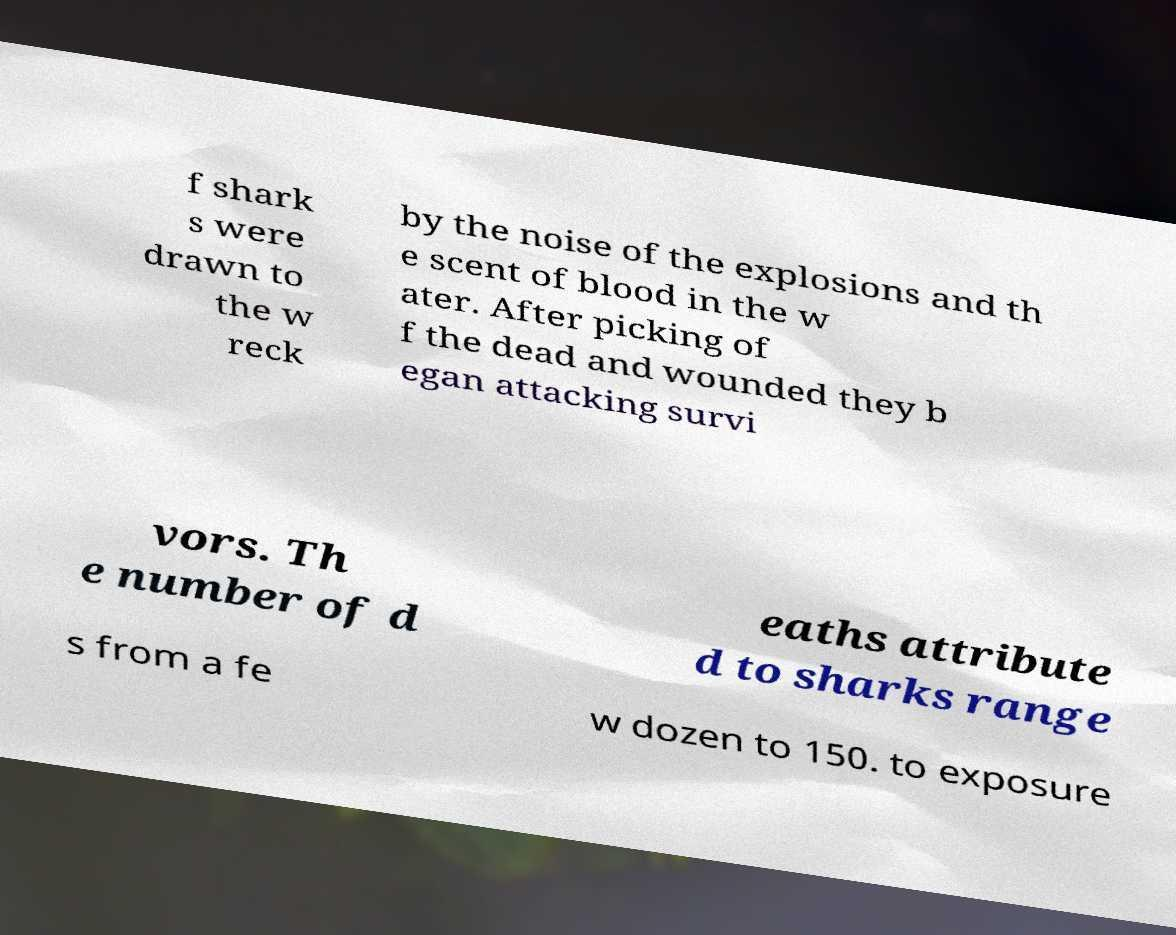There's text embedded in this image that I need extracted. Can you transcribe it verbatim? f shark s were drawn to the w reck by the noise of the explosions and th e scent of blood in the w ater. After picking of f the dead and wounded they b egan attacking survi vors. Th e number of d eaths attribute d to sharks range s from a fe w dozen to 150. to exposure 